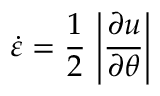<formula> <loc_0><loc_0><loc_500><loc_500>\dot { \varepsilon } = \frac { 1 } { 2 } \, \left | \frac { \partial u } { \partial \theta } \right |</formula> 